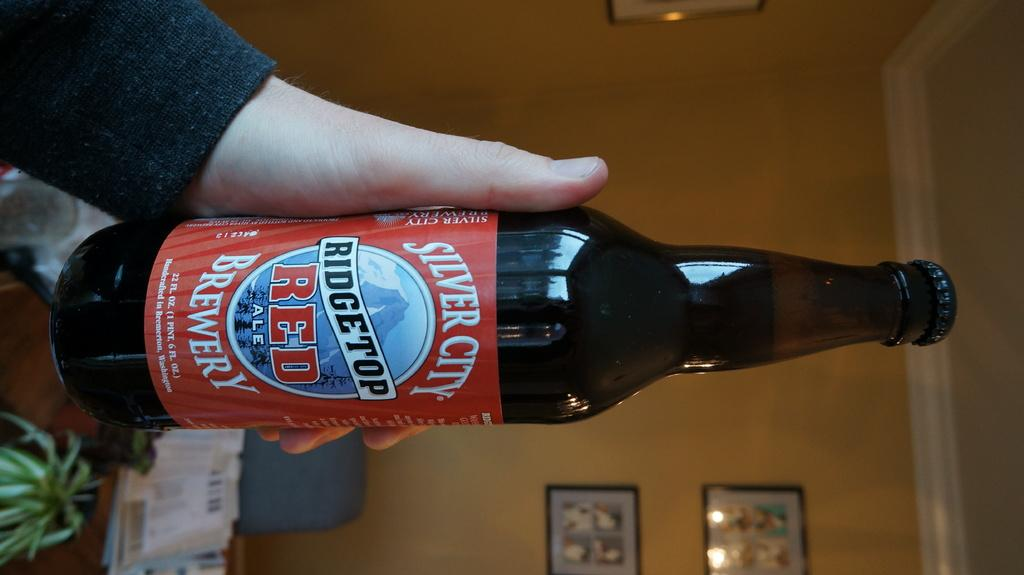<image>
Create a compact narrative representing the image presented. Person holding a Ridgetop Red ale from Silver City Brewery. 